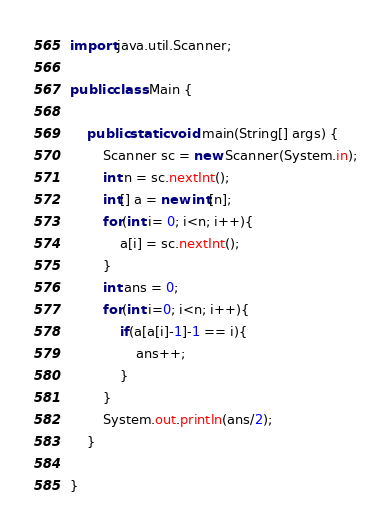Convert code to text. <code><loc_0><loc_0><loc_500><loc_500><_Java_>import java.util.Scanner;

public class Main {

	public static void main(String[] args) {
		Scanner sc = new Scanner(System.in);
		int n = sc.nextInt();
		int[] a = new int[n];
		for(int i= 0; i<n; i++){
			a[i] = sc.nextInt();
		}
		int ans = 0;
		for(int i=0; i<n; i++){
			if(a[a[i]-1]-1 == i){
				ans++;
			}
		}
		System.out.println(ans/2);
	}

}</code> 